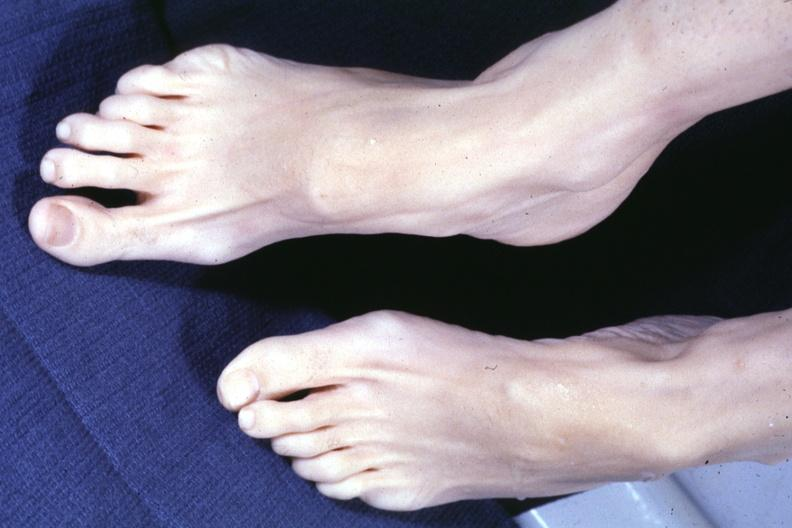what see other slide this interesting case?
Answer the question using a single word or phrase. Both feet with aortic dissection and mitral prolapse extremities which suggest marfans but no cystic aortic lesions 